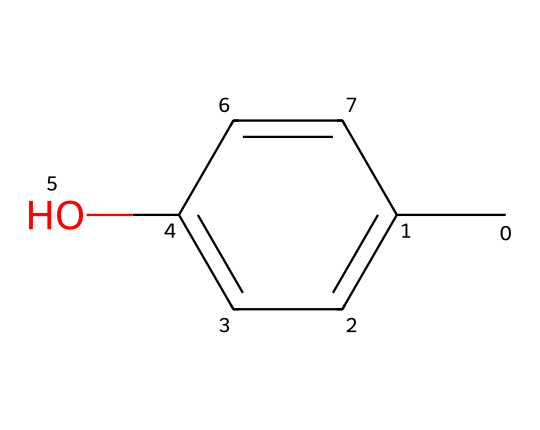What is the name of the compound represented by this structure? The SMILES notation provided corresponds to p-Cresol, as evidenced by the benzene ring and the presence of both a methyl group attached to the carbon (C) and a hydroxyl group (O) attached to the aromatic system.
Answer: p-Cresol How many carbon atoms are present in this molecule? By analyzing the structure, there are six carbon atoms in the benzene ring plus one additional carbon from the methyl group, totaling seven carbon atoms.
Answer: seven What functional group is present in p-Cresol? The chemical structure shows a hydroxyl group (-OH) attached to the benzene ring, which is characteristic of phenolic compounds.
Answer: hydroxyl How many hydrogen atoms are in this structure? Counting the hydrogen atoms attached to the six carbon atoms in the benzene ring (five hydrogen) and one from the methyl group, the total number of hydrogen atoms is six.
Answer: six What type of compound is p-Cresol classified as? p-Cresol contains a phenolic structure due to the presence of a hydroxyl group attached to a benzene ring, which classifies it as a phenol.
Answer: phenol What is the position of the hydroxyl group relative to the methyl group in p-Cresol? In the structure of p-Cresol, the hydroxyl group and the methyl group are both attached to the benzene ring at the para positions, indicating they are located opposite each other.
Answer: para Is p-Cresol likely to be soluble in water? Given the presence of a hydroxyl group in its structure, which is polar, p-Cresol is likely to be soluble in water due to hydrogen bonding with water molecules.
Answer: yes 